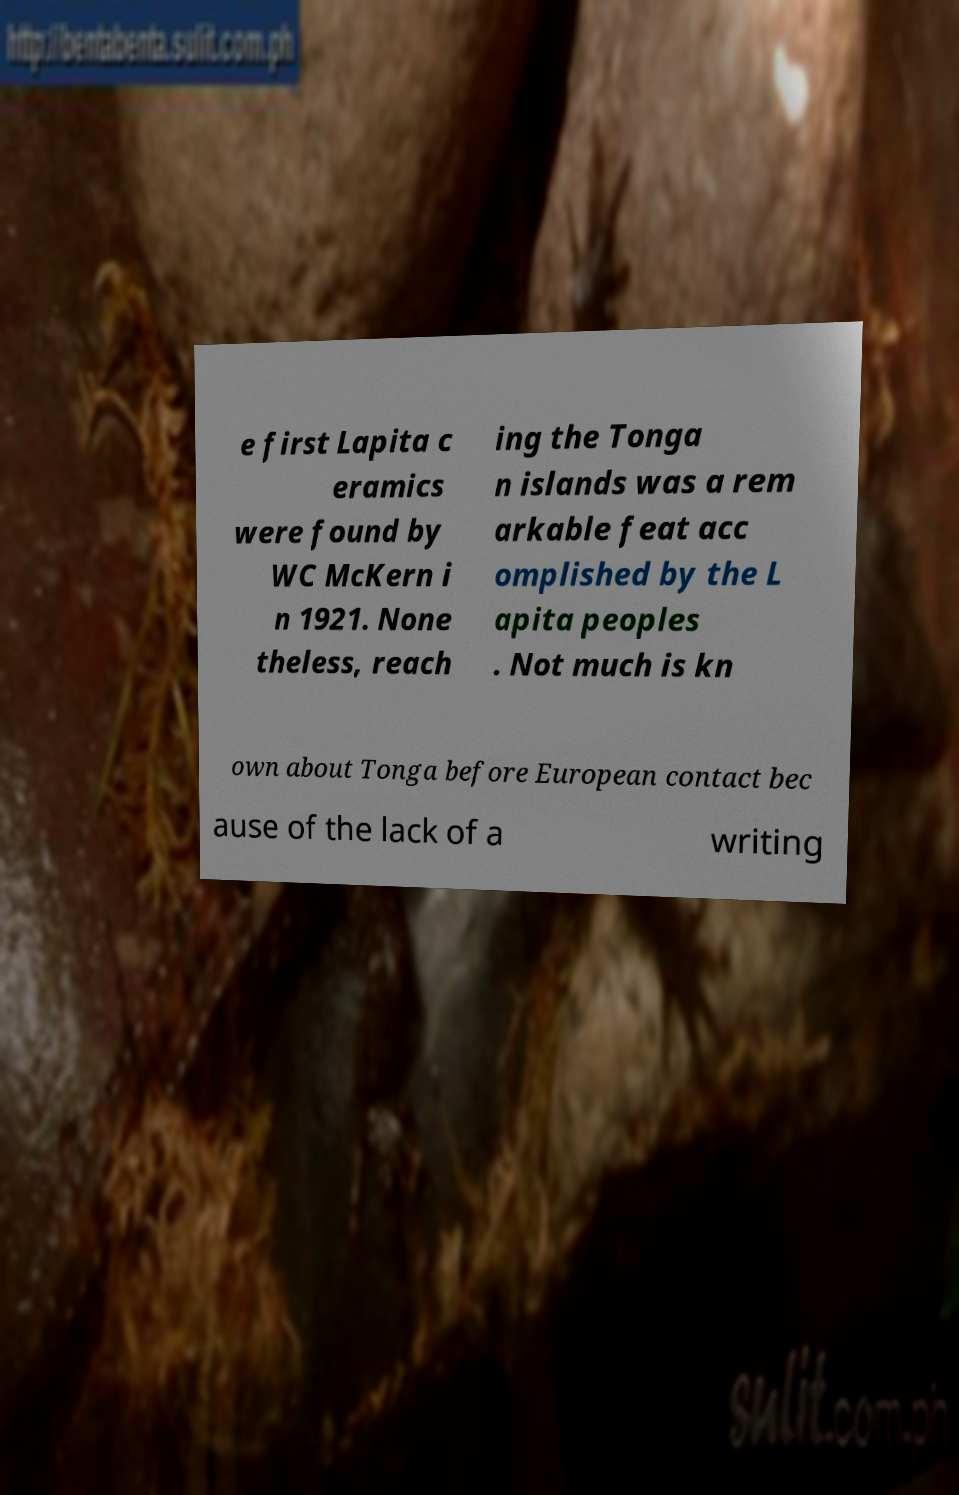Can you accurately transcribe the text from the provided image for me? e first Lapita c eramics were found by WC McKern i n 1921. None theless, reach ing the Tonga n islands was a rem arkable feat acc omplished by the L apita peoples . Not much is kn own about Tonga before European contact bec ause of the lack of a writing 